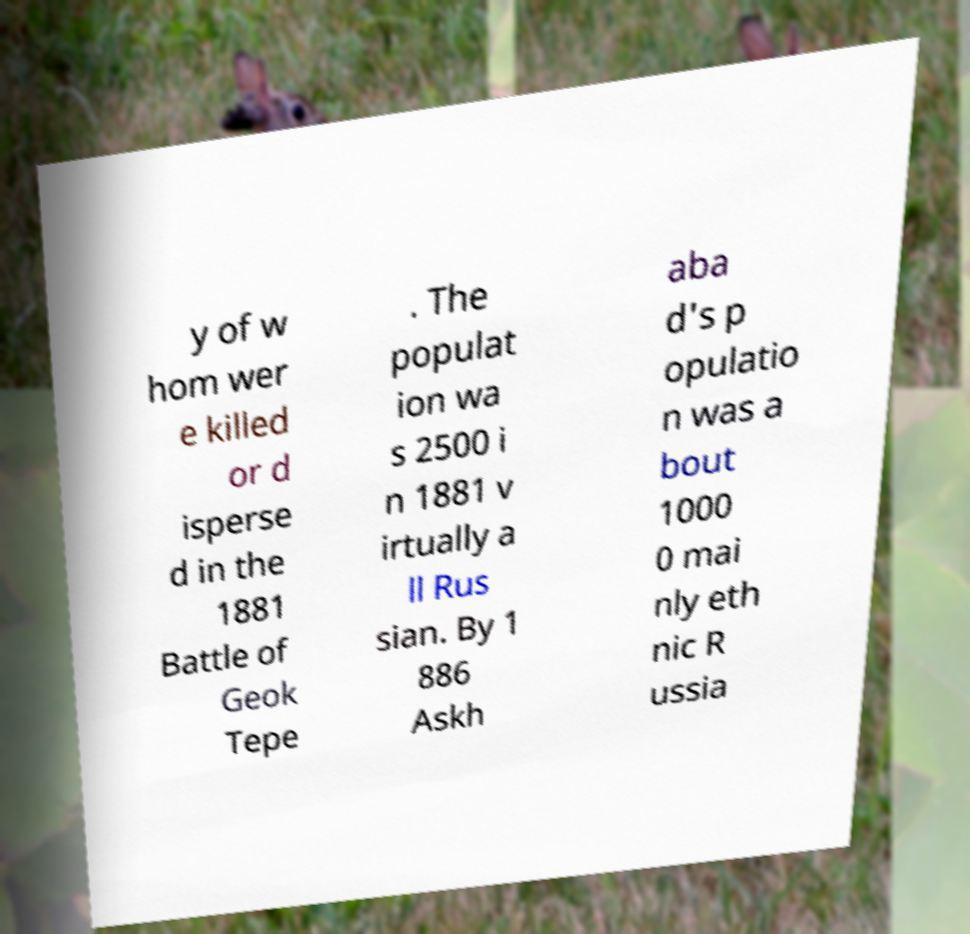Could you extract and type out the text from this image? y of w hom wer e killed or d isperse d in the 1881 Battle of Geok Tepe . The populat ion wa s 2500 i n 1881 v irtually a ll Rus sian. By 1 886 Askh aba d's p opulatio n was a bout 1000 0 mai nly eth nic R ussia 